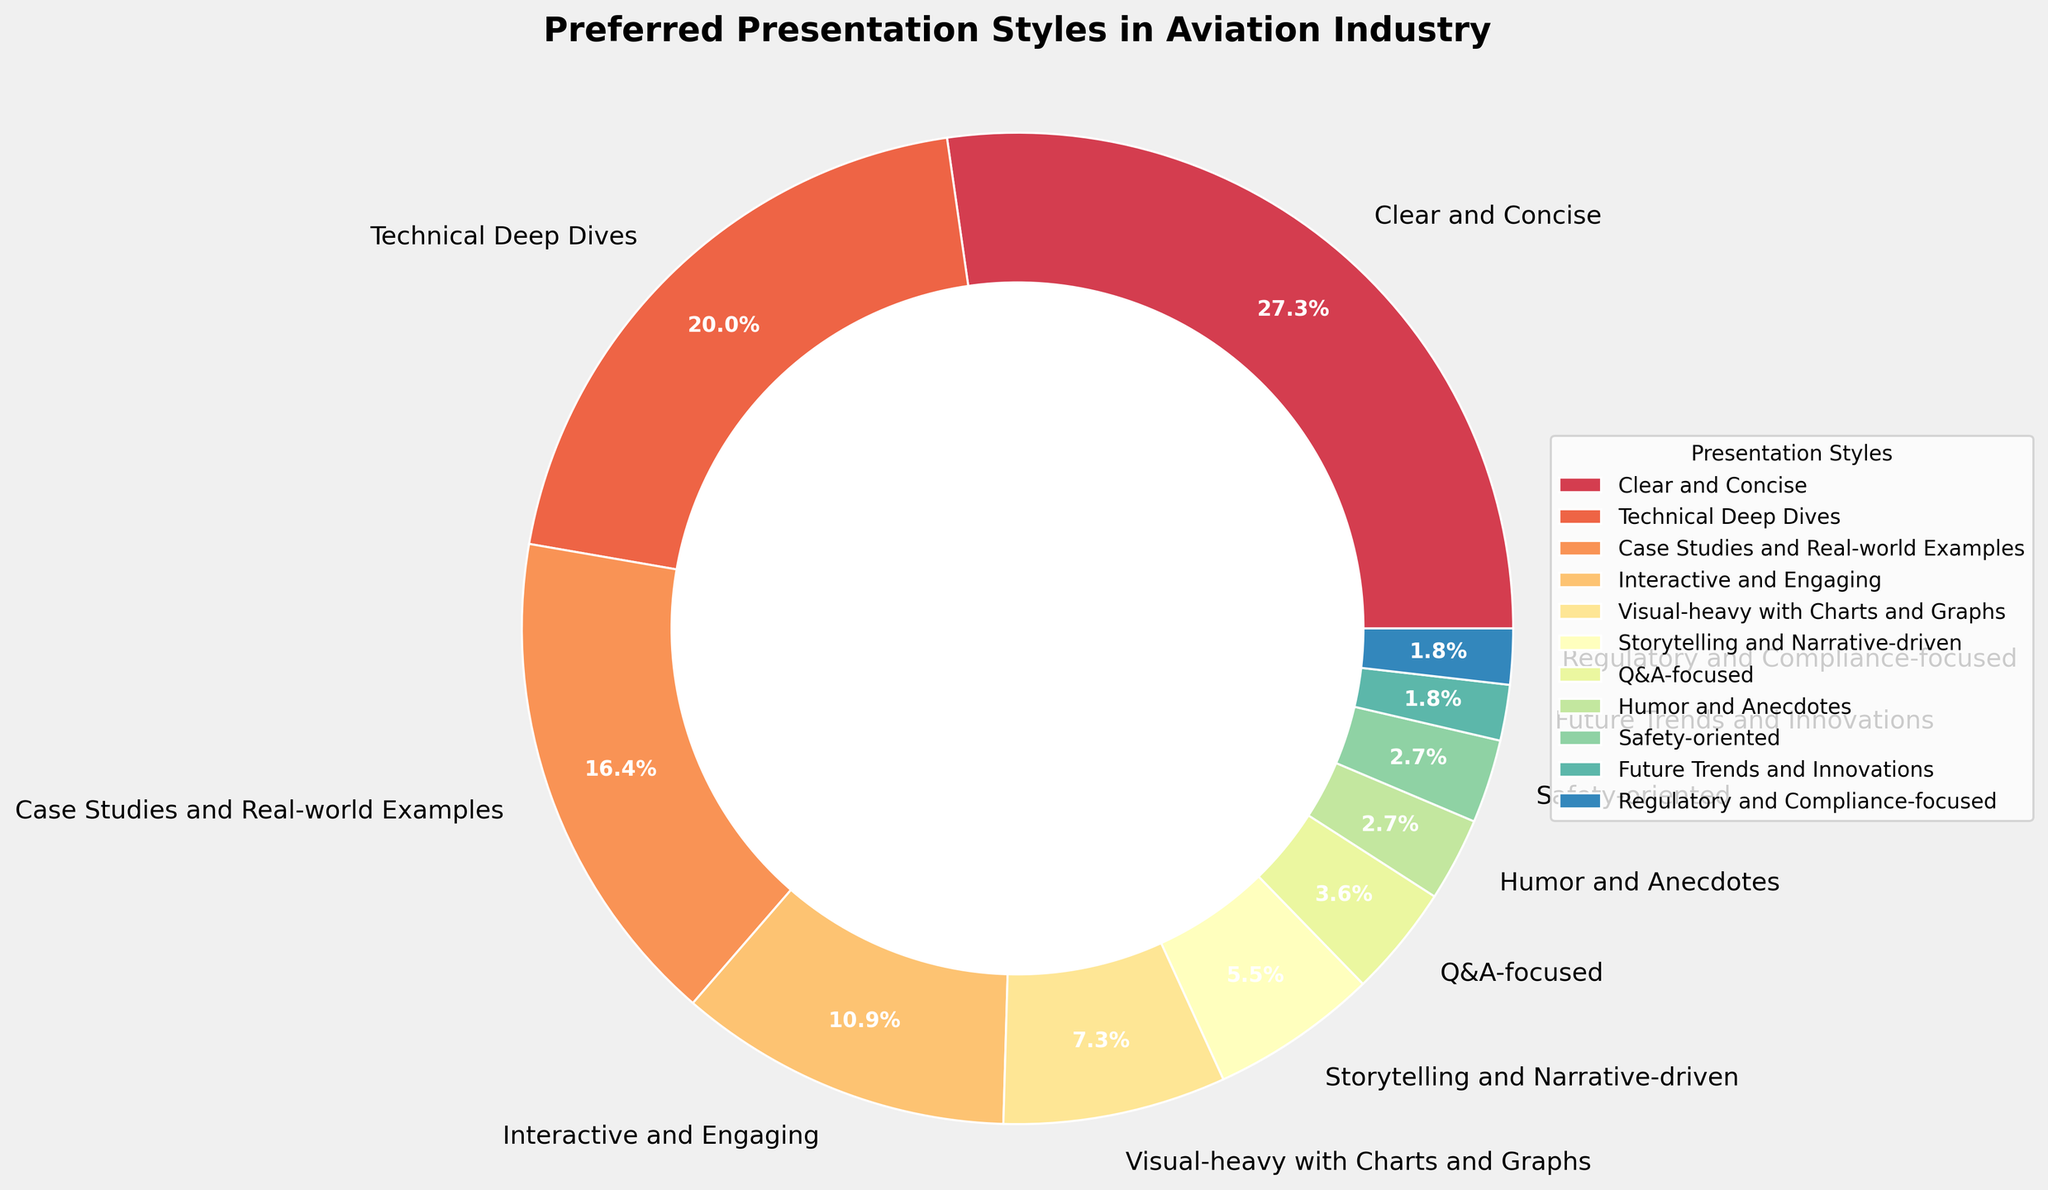What's the most preferred presentation style among aviation industry audiences? By examining the figure, we can see that the largest slice of the pie chart corresponds to "Clear and Concise" with 30%. Therefore, this is the most preferred style.
Answer: Clear and Concise How many presentation styles are there in total? Count the number of different slices in the pie chart, each representing a different presentation style. The data includes 11 different presentation styles.
Answer: 11 Which presentation style is least preferred and what's its percentage? Look for the smallest slice in the pie chart. The smallest slices are "Future Trends and Innovations" and "Regulatory and Compliance-focused," both with 2%.
Answer: Future Trends and Innovations and Regulatory and Compliance-focused, 2% Are there more audiences preferring "Technical Deep Dives" than "Case Studies and Real-world Examples"? Compare the percentages of these two presentation styles from the figure. "Technical Deep Dives" has 22% while "Case Studies and Real-world Examples" has 18%.
Answer: Yes What is the combined preference percentage for "Humor and Anecdotes" and "Safety-oriented"? Sum the percentages of these two styles: 3% (Humor and Anecdotes) + 3% (Safety-oriented) = 6%.
Answer: 6% Does the preference for "Interactive and Engaging" exceed that for "Visual-heavy with Charts and Graphs"? Compare the percentages for these two styles. "Interactive and Engaging" has 12% while "Visual-heavy with Charts and Graphs" has 8%.
Answer: Yes Which segment has a similar preference percentage to "Storytelling and Narrative-driven"? Identify the slice with a percentage close to that of "Storytelling and Narrative-driven" (6%). "Q&A-focused" has a similar percentage with 4%.
Answer: Q&A-focused What is the difference in preference percentage between the highest and lowest preferred presentation styles? Subtract the percentage of the least preferred style (2%) from the most preferred style (30%): 30% - 2% = 28%.
Answer: 28% What percentage of audiences prefer "Case Studies and Real-world Examples" or "Interactive and Engaging" combined? Sum the percentages for these two styles: 18% (Case Studies and Real-world Examples) + 12% (Interactive and Engaging) = 30%.
Answer: 30% How does the preference for "Q&A-focused" presentations compare to that for "Regulatory and Compliance-focused" presentations? Compare the percentages for these two styles directly. "Q&A-focused" has 4% while "Regulatory and Compliance-focused" has 2%.
Answer: Q&A-focused is more preferred 